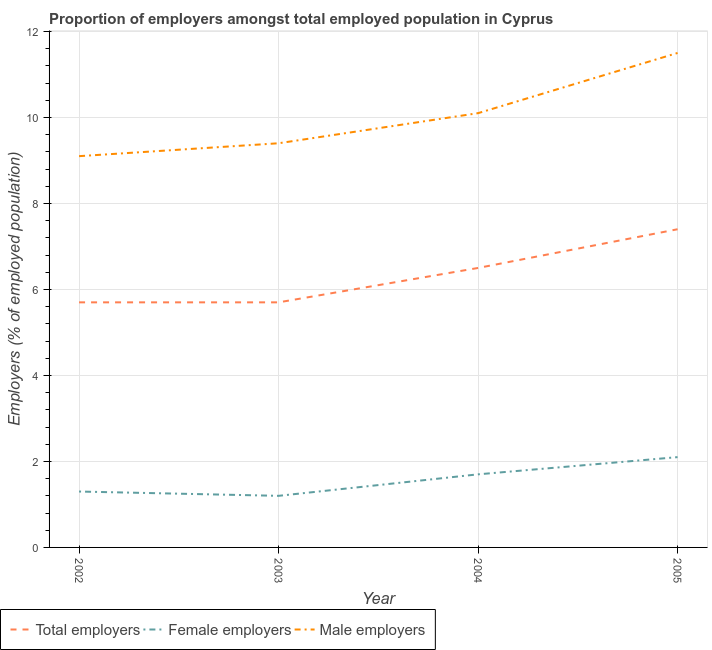What is the percentage of female employers in 2005?
Give a very brief answer. 2.1. Across all years, what is the minimum percentage of female employers?
Keep it short and to the point. 1.2. In which year was the percentage of male employers maximum?
Offer a terse response. 2005. What is the total percentage of female employers in the graph?
Give a very brief answer. 6.3. What is the difference between the percentage of male employers in 2004 and that in 2005?
Your answer should be very brief. -1.4. What is the difference between the percentage of total employers in 2004 and the percentage of male employers in 2002?
Your response must be concise. -2.6. What is the average percentage of female employers per year?
Offer a terse response. 1.57. In the year 2003, what is the difference between the percentage of female employers and percentage of total employers?
Offer a terse response. -4.5. In how many years, is the percentage of female employers greater than 9.2 %?
Provide a succinct answer. 0. What is the ratio of the percentage of female employers in 2004 to that in 2005?
Your response must be concise. 0.81. Is the percentage of female employers in 2003 less than that in 2004?
Make the answer very short. Yes. What is the difference between the highest and the second highest percentage of male employers?
Make the answer very short. 1.4. What is the difference between the highest and the lowest percentage of total employers?
Offer a very short reply. 1.7. Is the sum of the percentage of male employers in 2004 and 2005 greater than the maximum percentage of female employers across all years?
Offer a very short reply. Yes. Does the percentage of female employers monotonically increase over the years?
Provide a succinct answer. No. Is the percentage of male employers strictly greater than the percentage of total employers over the years?
Provide a short and direct response. Yes. Is the percentage of female employers strictly less than the percentage of total employers over the years?
Offer a very short reply. Yes. How many lines are there?
Make the answer very short. 3. How many years are there in the graph?
Offer a very short reply. 4. What is the difference between two consecutive major ticks on the Y-axis?
Your answer should be compact. 2. Are the values on the major ticks of Y-axis written in scientific E-notation?
Offer a very short reply. No. Does the graph contain any zero values?
Your response must be concise. No. Where does the legend appear in the graph?
Keep it short and to the point. Bottom left. What is the title of the graph?
Make the answer very short. Proportion of employers amongst total employed population in Cyprus. What is the label or title of the X-axis?
Provide a succinct answer. Year. What is the label or title of the Y-axis?
Provide a short and direct response. Employers (% of employed population). What is the Employers (% of employed population) of Total employers in 2002?
Make the answer very short. 5.7. What is the Employers (% of employed population) of Female employers in 2002?
Offer a terse response. 1.3. What is the Employers (% of employed population) of Male employers in 2002?
Your answer should be very brief. 9.1. What is the Employers (% of employed population) in Total employers in 2003?
Provide a short and direct response. 5.7. What is the Employers (% of employed population) in Female employers in 2003?
Offer a terse response. 1.2. What is the Employers (% of employed population) in Male employers in 2003?
Make the answer very short. 9.4. What is the Employers (% of employed population) of Total employers in 2004?
Offer a terse response. 6.5. What is the Employers (% of employed population) of Female employers in 2004?
Provide a short and direct response. 1.7. What is the Employers (% of employed population) in Male employers in 2004?
Your response must be concise. 10.1. What is the Employers (% of employed population) in Total employers in 2005?
Keep it short and to the point. 7.4. What is the Employers (% of employed population) in Female employers in 2005?
Make the answer very short. 2.1. What is the Employers (% of employed population) of Male employers in 2005?
Ensure brevity in your answer.  11.5. Across all years, what is the maximum Employers (% of employed population) of Total employers?
Your response must be concise. 7.4. Across all years, what is the maximum Employers (% of employed population) of Female employers?
Offer a very short reply. 2.1. Across all years, what is the minimum Employers (% of employed population) of Total employers?
Ensure brevity in your answer.  5.7. Across all years, what is the minimum Employers (% of employed population) in Female employers?
Provide a short and direct response. 1.2. Across all years, what is the minimum Employers (% of employed population) of Male employers?
Offer a terse response. 9.1. What is the total Employers (% of employed population) in Total employers in the graph?
Provide a succinct answer. 25.3. What is the total Employers (% of employed population) of Male employers in the graph?
Provide a short and direct response. 40.1. What is the difference between the Employers (% of employed population) of Total employers in 2002 and that in 2003?
Offer a terse response. 0. What is the difference between the Employers (% of employed population) of Total employers in 2002 and that in 2004?
Provide a short and direct response. -0.8. What is the difference between the Employers (% of employed population) in Male employers in 2002 and that in 2004?
Provide a short and direct response. -1. What is the difference between the Employers (% of employed population) of Male employers in 2003 and that in 2004?
Your answer should be very brief. -0.7. What is the difference between the Employers (% of employed population) of Total employers in 2003 and that in 2005?
Ensure brevity in your answer.  -1.7. What is the difference between the Employers (% of employed population) of Female employers in 2003 and that in 2005?
Ensure brevity in your answer.  -0.9. What is the difference between the Employers (% of employed population) of Male employers in 2003 and that in 2005?
Offer a terse response. -2.1. What is the difference between the Employers (% of employed population) of Female employers in 2004 and that in 2005?
Keep it short and to the point. -0.4. What is the difference between the Employers (% of employed population) of Total employers in 2002 and the Employers (% of employed population) of Female employers in 2003?
Give a very brief answer. 4.5. What is the difference between the Employers (% of employed population) in Total employers in 2002 and the Employers (% of employed population) in Male employers in 2003?
Your response must be concise. -3.7. What is the difference between the Employers (% of employed population) in Female employers in 2002 and the Employers (% of employed population) in Male employers in 2003?
Provide a succinct answer. -8.1. What is the difference between the Employers (% of employed population) of Female employers in 2002 and the Employers (% of employed population) of Male employers in 2004?
Offer a very short reply. -8.8. What is the difference between the Employers (% of employed population) of Total employers in 2003 and the Employers (% of employed population) of Female employers in 2004?
Give a very brief answer. 4. What is the difference between the Employers (% of employed population) in Total employers in 2003 and the Employers (% of employed population) in Male employers in 2005?
Your response must be concise. -5.8. What is the difference between the Employers (% of employed population) in Female employers in 2003 and the Employers (% of employed population) in Male employers in 2005?
Provide a short and direct response. -10.3. What is the average Employers (% of employed population) in Total employers per year?
Your response must be concise. 6.33. What is the average Employers (% of employed population) of Female employers per year?
Make the answer very short. 1.57. What is the average Employers (% of employed population) in Male employers per year?
Your answer should be compact. 10.03. In the year 2002, what is the difference between the Employers (% of employed population) of Total employers and Employers (% of employed population) of Female employers?
Offer a very short reply. 4.4. In the year 2002, what is the difference between the Employers (% of employed population) of Total employers and Employers (% of employed population) of Male employers?
Ensure brevity in your answer.  -3.4. In the year 2003, what is the difference between the Employers (% of employed population) in Total employers and Employers (% of employed population) in Female employers?
Make the answer very short. 4.5. In the year 2003, what is the difference between the Employers (% of employed population) of Total employers and Employers (% of employed population) of Male employers?
Your answer should be very brief. -3.7. In the year 2003, what is the difference between the Employers (% of employed population) in Female employers and Employers (% of employed population) in Male employers?
Your answer should be compact. -8.2. In the year 2004, what is the difference between the Employers (% of employed population) in Total employers and Employers (% of employed population) in Female employers?
Provide a succinct answer. 4.8. In the year 2004, what is the difference between the Employers (% of employed population) in Total employers and Employers (% of employed population) in Male employers?
Offer a terse response. -3.6. What is the ratio of the Employers (% of employed population) in Total employers in 2002 to that in 2003?
Your answer should be very brief. 1. What is the ratio of the Employers (% of employed population) of Female employers in 2002 to that in 2003?
Provide a succinct answer. 1.08. What is the ratio of the Employers (% of employed population) of Male employers in 2002 to that in 2003?
Your response must be concise. 0.97. What is the ratio of the Employers (% of employed population) of Total employers in 2002 to that in 2004?
Ensure brevity in your answer.  0.88. What is the ratio of the Employers (% of employed population) in Female employers in 2002 to that in 2004?
Offer a terse response. 0.76. What is the ratio of the Employers (% of employed population) of Male employers in 2002 to that in 2004?
Your answer should be compact. 0.9. What is the ratio of the Employers (% of employed population) in Total employers in 2002 to that in 2005?
Provide a short and direct response. 0.77. What is the ratio of the Employers (% of employed population) of Female employers in 2002 to that in 2005?
Your answer should be compact. 0.62. What is the ratio of the Employers (% of employed population) of Male employers in 2002 to that in 2005?
Offer a terse response. 0.79. What is the ratio of the Employers (% of employed population) in Total employers in 2003 to that in 2004?
Offer a very short reply. 0.88. What is the ratio of the Employers (% of employed population) in Female employers in 2003 to that in 2004?
Your response must be concise. 0.71. What is the ratio of the Employers (% of employed population) of Male employers in 2003 to that in 2004?
Provide a succinct answer. 0.93. What is the ratio of the Employers (% of employed population) in Total employers in 2003 to that in 2005?
Keep it short and to the point. 0.77. What is the ratio of the Employers (% of employed population) in Male employers in 2003 to that in 2005?
Provide a short and direct response. 0.82. What is the ratio of the Employers (% of employed population) of Total employers in 2004 to that in 2005?
Your answer should be compact. 0.88. What is the ratio of the Employers (% of employed population) in Female employers in 2004 to that in 2005?
Offer a terse response. 0.81. What is the ratio of the Employers (% of employed population) in Male employers in 2004 to that in 2005?
Your answer should be very brief. 0.88. What is the difference between the highest and the second highest Employers (% of employed population) of Female employers?
Your answer should be very brief. 0.4. What is the difference between the highest and the lowest Employers (% of employed population) in Total employers?
Give a very brief answer. 1.7. What is the difference between the highest and the lowest Employers (% of employed population) in Female employers?
Your answer should be compact. 0.9. 